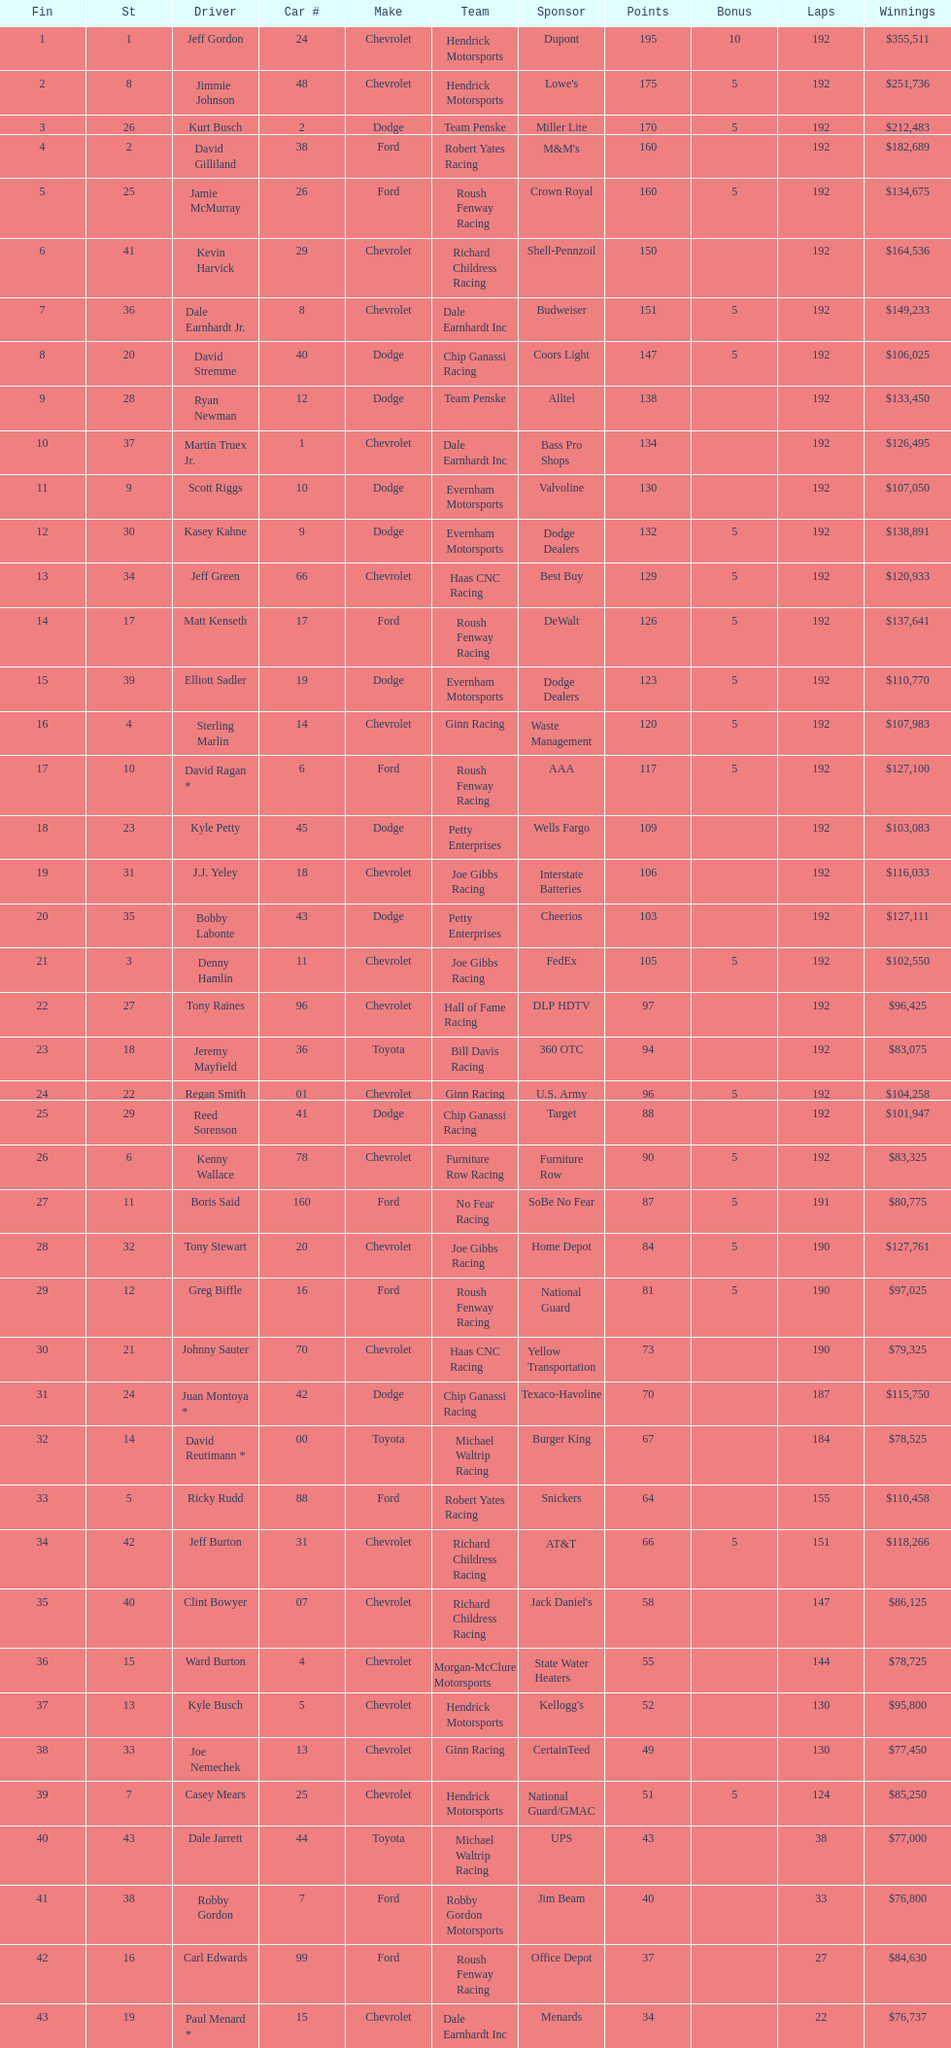How many drivers earned 5 bonus each in the race? 19. 